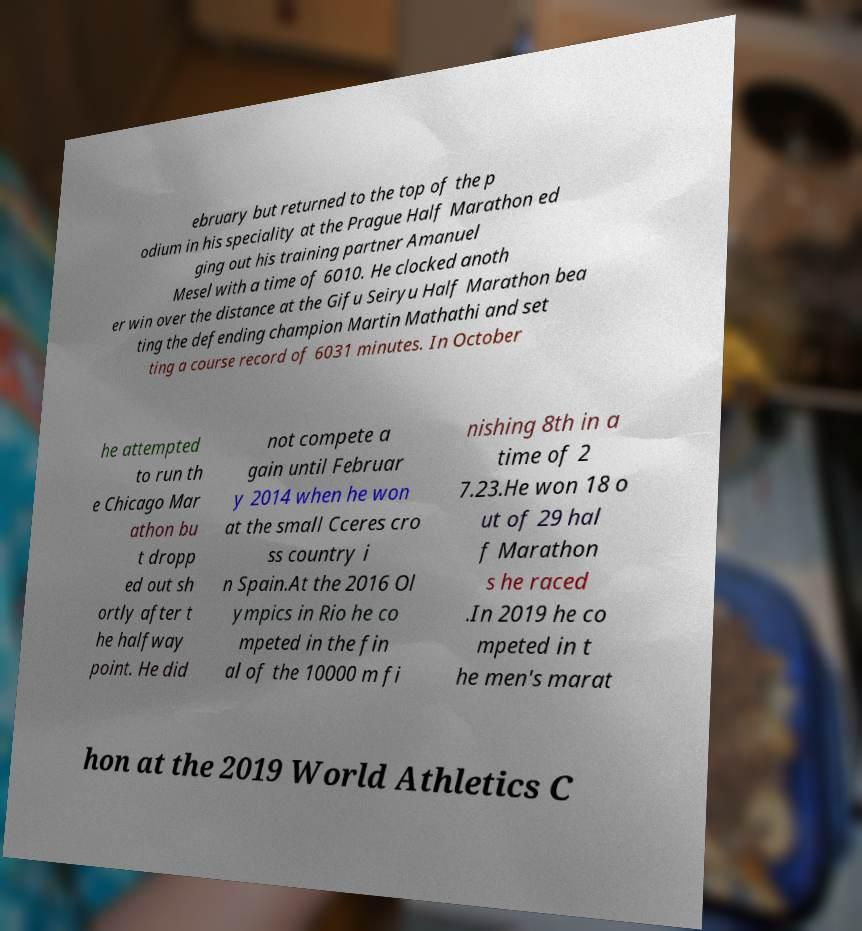Could you assist in decoding the text presented in this image and type it out clearly? ebruary but returned to the top of the p odium in his speciality at the Prague Half Marathon ed ging out his training partner Amanuel Mesel with a time of 6010. He clocked anoth er win over the distance at the Gifu Seiryu Half Marathon bea ting the defending champion Martin Mathathi and set ting a course record of 6031 minutes. In October he attempted to run th e Chicago Mar athon bu t dropp ed out sh ortly after t he halfway point. He did not compete a gain until Februar y 2014 when he won at the small Cceres cro ss country i n Spain.At the 2016 Ol ympics in Rio he co mpeted in the fin al of the 10000 m fi nishing 8th in a time of 2 7.23.He won 18 o ut of 29 hal f Marathon s he raced .In 2019 he co mpeted in t he men's marat hon at the 2019 World Athletics C 